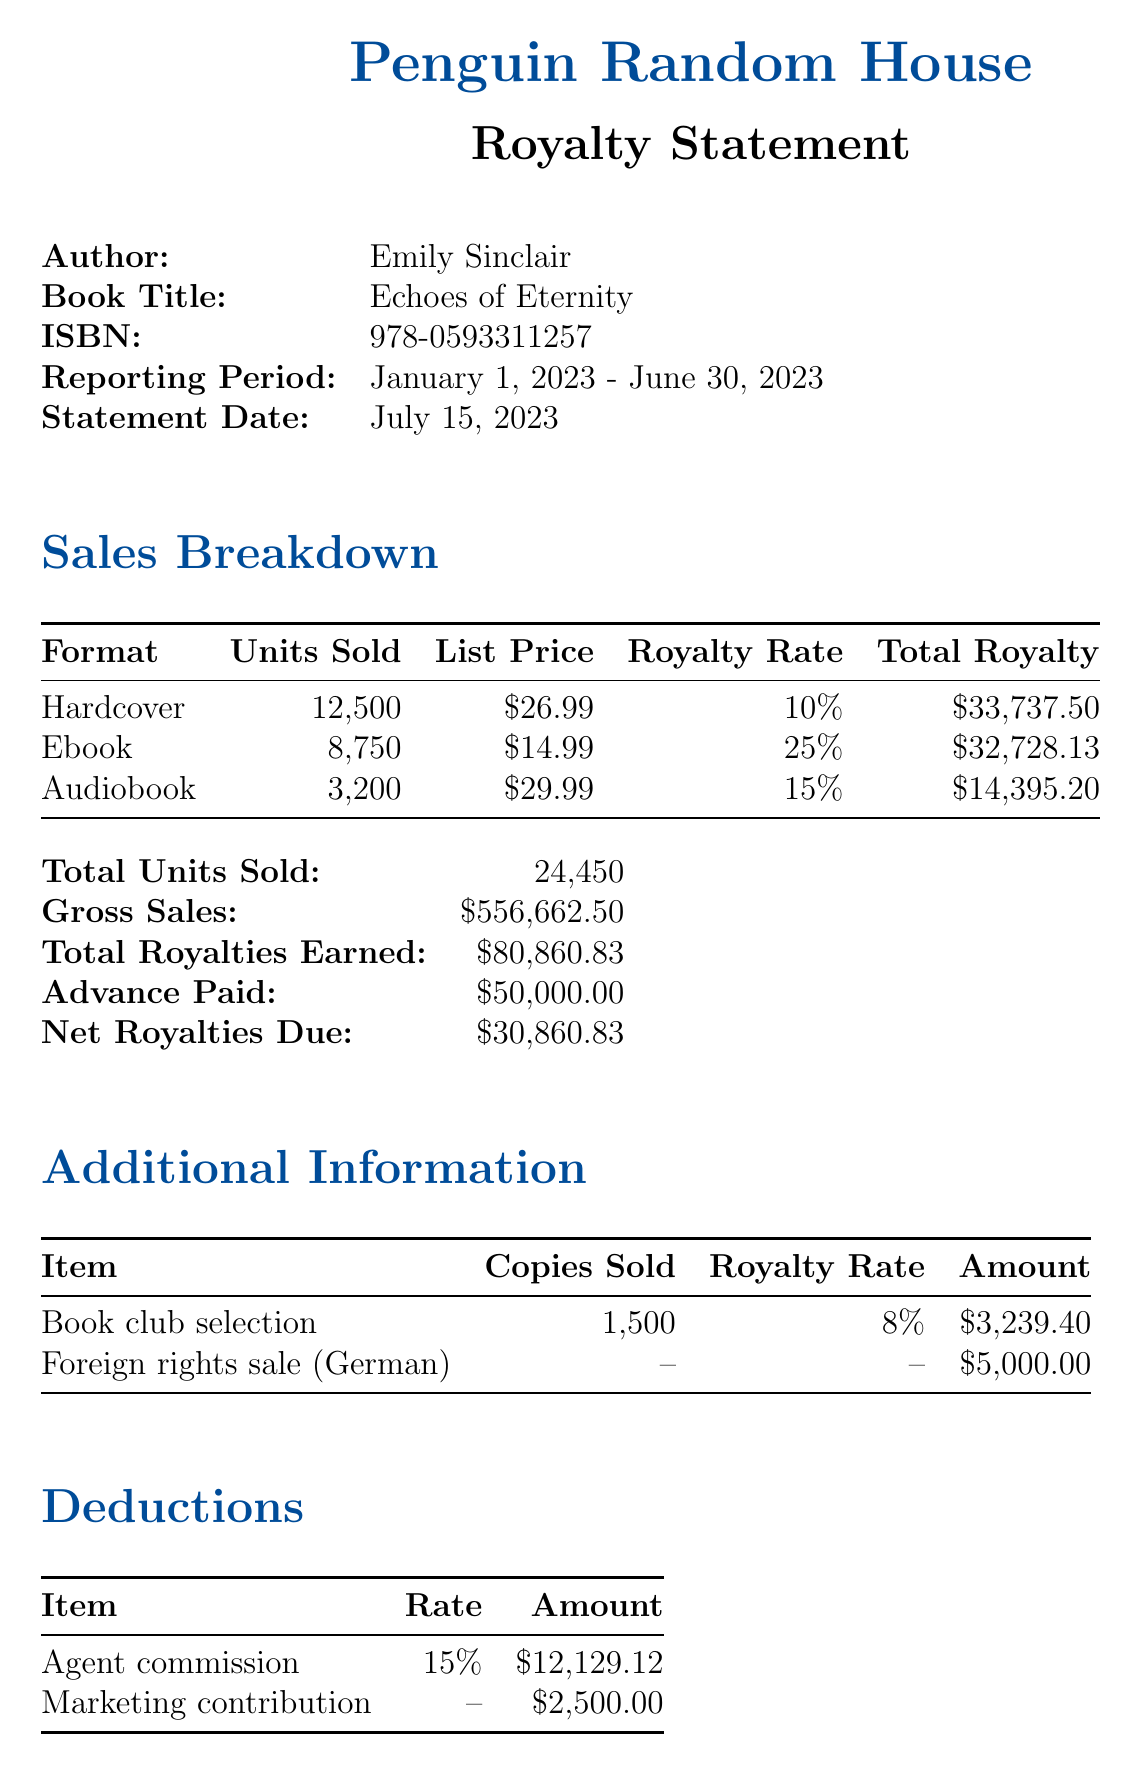what is the publisher name? The publisher name is listed at the top of the document, which is Penguin Random House.
Answer: Penguin Random House what is the total number of units sold? The total number of units sold is stated clearly in the sales breakdown section of the document.
Answer: 24,450 what is the royalty rate for ebooks? The royalty rate for ebooks is specified in the sales breakdown section.
Answer: 25% how much was the advance paid? The advance paid is detailed towards the end of the main financial information.
Answer: $50,000.00 what is the total royalties earned? The total royalties earned is indicated in the financial summary and is the sum of all royalties from different formats.
Answer: $80,860.83 how much is the agent commission? The agent commission is listed in the deductions section of the document.
Answer: $12,129.12 how much did the book club selection earn? The earnings from the book club selection are listed in the additional information section of the document.
Answer: $3,239.40 what is the payment method for the royalties? The payment method is stated clearly under the payment details section of the document.
Answer: Direct deposit who should be contacted for questions regarding the statement? The publisher contact section lists the individual responsible for royalty inquiries.
Answer: Sarah Thompson 